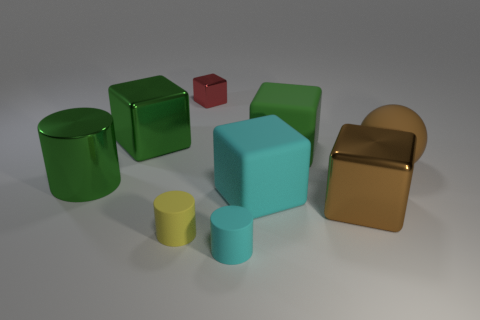Subtract all big green metal blocks. How many blocks are left? 4 Subtract all brown blocks. How many blocks are left? 4 Subtract 1 spheres. How many spheres are left? 0 Add 1 tiny blue metal cylinders. How many objects exist? 10 Subtract all cylinders. How many objects are left? 6 Subtract all gray blocks. Subtract all green spheres. How many blocks are left? 5 Subtract all brown blocks. How many cyan cylinders are left? 1 Subtract all large matte blocks. Subtract all blue rubber objects. How many objects are left? 7 Add 2 tiny red shiny blocks. How many tiny red shiny blocks are left? 3 Add 5 red shiny objects. How many red shiny objects exist? 6 